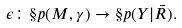Convert formula to latex. <formula><loc_0><loc_0><loc_500><loc_500>\epsilon \colon \S p ( M , \gamma ) \to \S p ( Y | \bar { R } ) .</formula> 